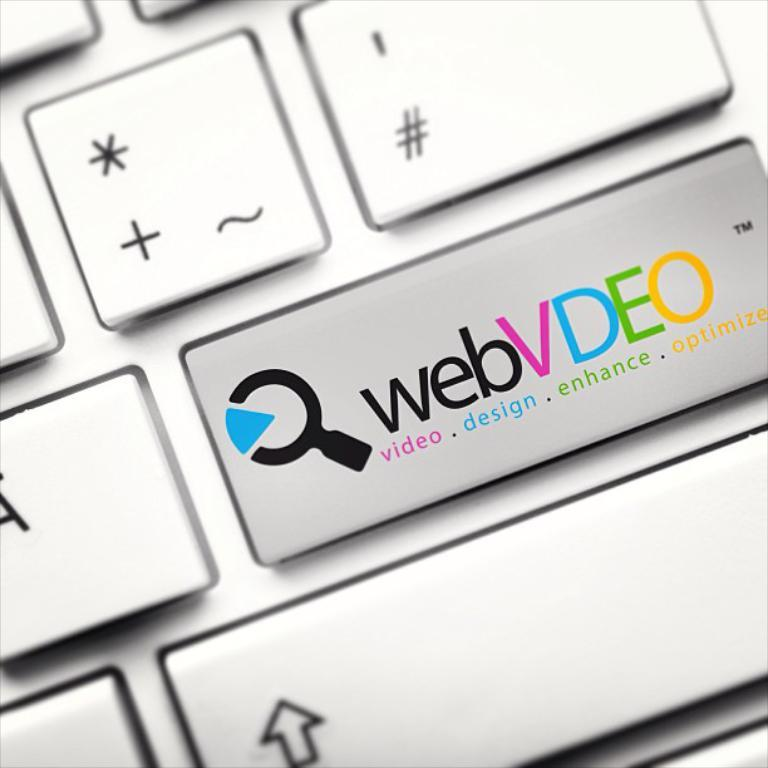<image>
Relay a brief, clear account of the picture shown. a webvdeo laptop with it slogon video design enchance optimize 